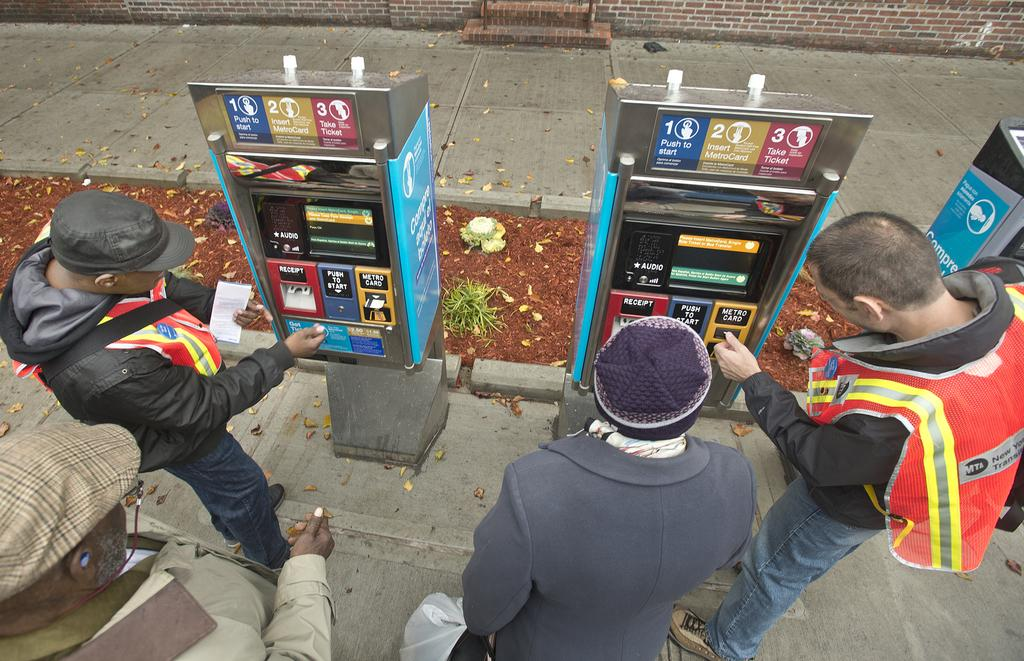How many men are present in the image? There are four men standing in front of machines. What are the machines used for? The machines resemble ATMs, which are typically used for financial transactions. Where are the machines located? The machines are placed on the road. What can be seen at the top of the image? There is a wall visible at the top of the image. Can you see a baby playing with a boot in the image? There is no baby or boot present in the image. 